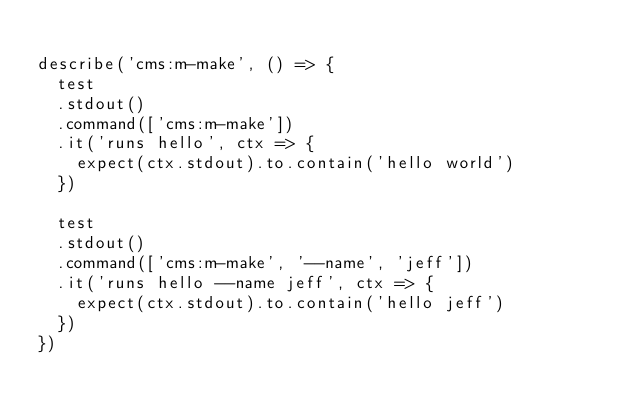Convert code to text. <code><loc_0><loc_0><loc_500><loc_500><_TypeScript_>
describe('cms:m-make', () => {
  test
  .stdout()
  .command(['cms:m-make'])
  .it('runs hello', ctx => {
    expect(ctx.stdout).to.contain('hello world')
  })

  test
  .stdout()
  .command(['cms:m-make', '--name', 'jeff'])
  .it('runs hello --name jeff', ctx => {
    expect(ctx.stdout).to.contain('hello jeff')
  })
})
</code> 